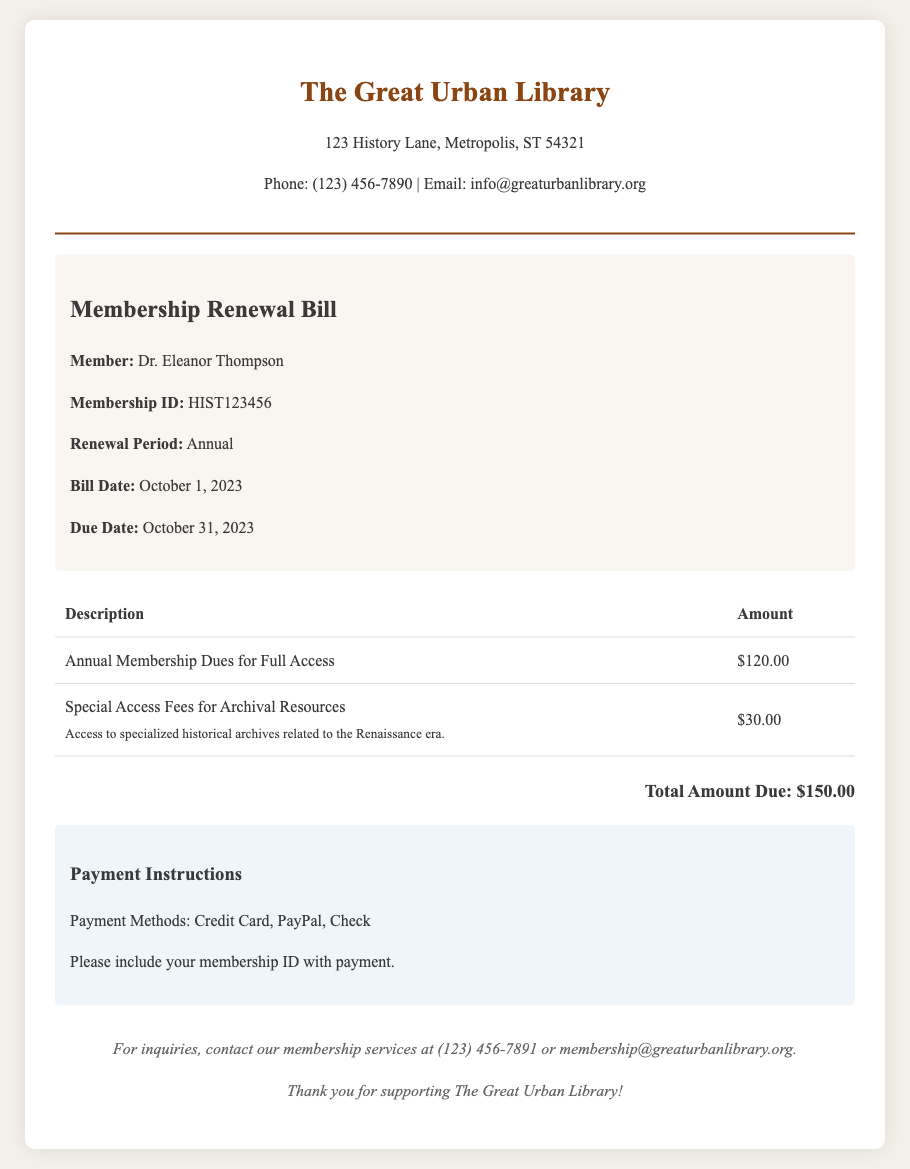What is the total amount due? The total amount due is stated at the bottom of the billing details section.
Answer: $150.00 What is the member's name? The member's name is provided in the member information section.
Answer: Dr. Eleanor Thompson What is the renewal period? The renewal period specifies how long the membership will be valid and is noted in the member information section.
Answer: Annual When is the due date? The due date for the payment is clearly indicated in the member information section.
Answer: October 31, 2023 What are the special access fees for? The special access fees are described in the billing details and specify what archives are related to.
Answer: Archival Resources What payment methods are accepted? The payment methods are listed in the payment instructions section of the document.
Answer: Credit Card, PayPal, Check What is the membership ID? The membership ID is given in the member information section.
Answer: HIST123456 What is the bill date? The bill date indicates when the bill was issued and is found in the member information section.
Answer: October 1, 2023 